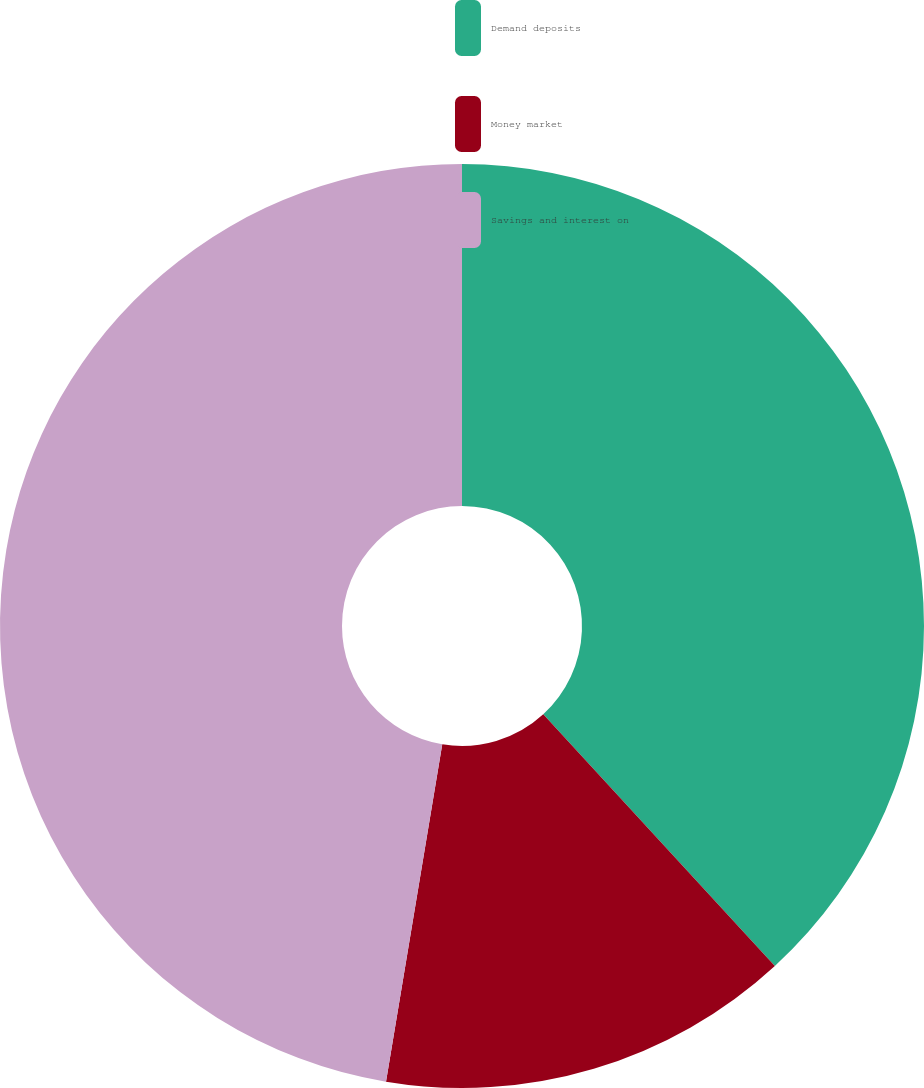<chart> <loc_0><loc_0><loc_500><loc_500><pie_chart><fcel>Demand deposits<fcel>Money market<fcel>Savings and interest on<nl><fcel>38.16%<fcel>14.47%<fcel>47.37%<nl></chart> 